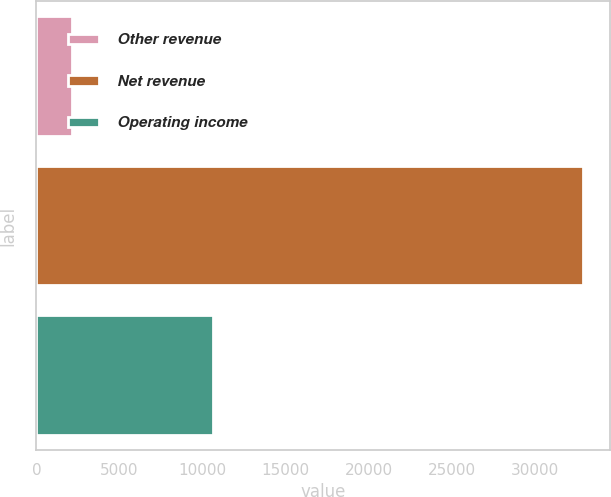Convert chart. <chart><loc_0><loc_0><loc_500><loc_500><bar_chart><fcel>Other revenue<fcel>Net revenue<fcel>Operating income<nl><fcel>2157<fcel>32908<fcel>10646<nl></chart> 